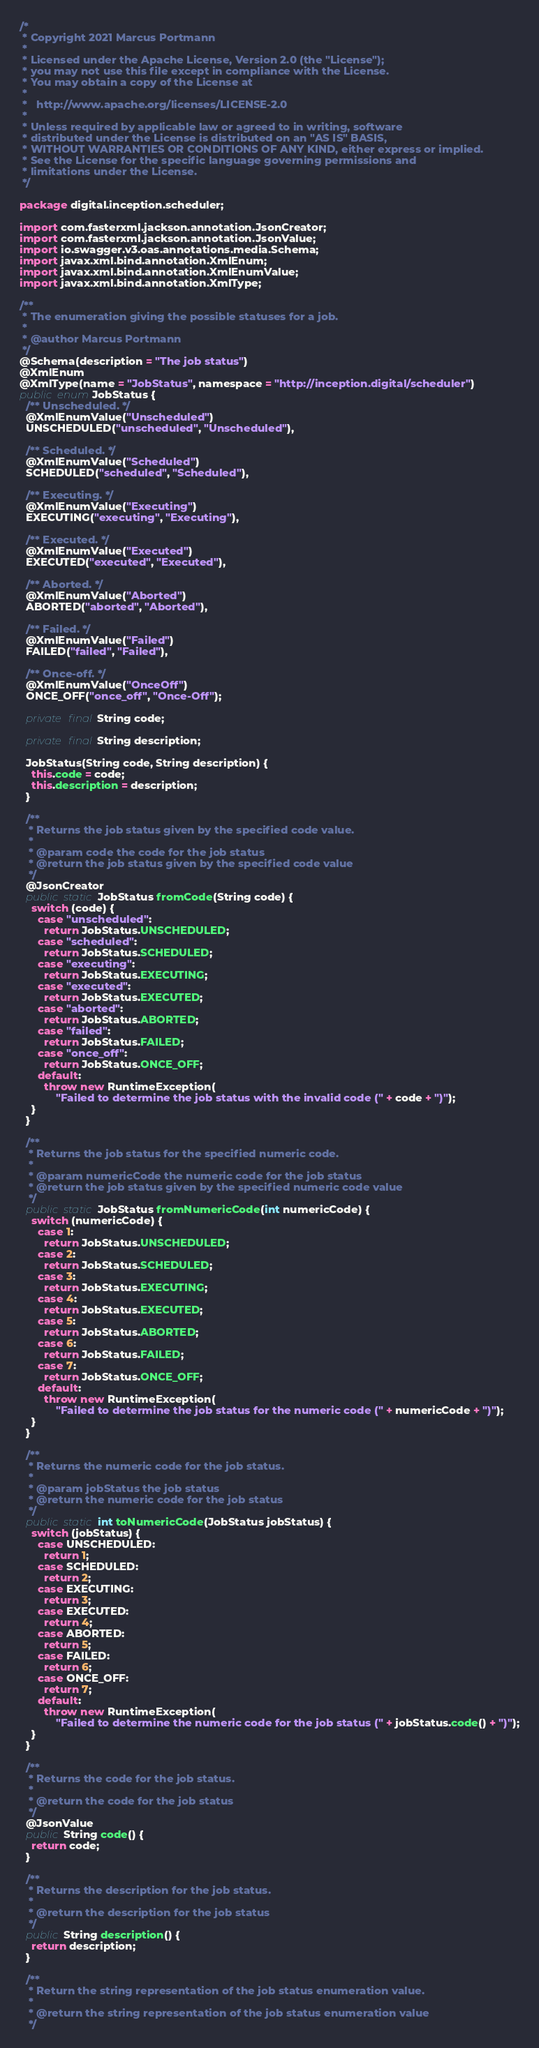Convert code to text. <code><loc_0><loc_0><loc_500><loc_500><_Java_>/*
 * Copyright 2021 Marcus Portmann
 *
 * Licensed under the Apache License, Version 2.0 (the "License");
 * you may not use this file except in compliance with the License.
 * You may obtain a copy of the License at
 *
 *   http://www.apache.org/licenses/LICENSE-2.0
 *
 * Unless required by applicable law or agreed to in writing, software
 * distributed under the License is distributed on an "AS IS" BASIS,
 * WITHOUT WARRANTIES OR CONDITIONS OF ANY KIND, either express or implied.
 * See the License for the specific language governing permissions and
 * limitations under the License.
 */

package digital.inception.scheduler;

import com.fasterxml.jackson.annotation.JsonCreator;
import com.fasterxml.jackson.annotation.JsonValue;
import io.swagger.v3.oas.annotations.media.Schema;
import javax.xml.bind.annotation.XmlEnum;
import javax.xml.bind.annotation.XmlEnumValue;
import javax.xml.bind.annotation.XmlType;

/**
 * The enumeration giving the possible statuses for a job.
 *
 * @author Marcus Portmann
 */
@Schema(description = "The job status")
@XmlEnum
@XmlType(name = "JobStatus", namespace = "http://inception.digital/scheduler")
public enum JobStatus {
  /** Unscheduled. */
  @XmlEnumValue("Unscheduled")
  UNSCHEDULED("unscheduled", "Unscheduled"),

  /** Scheduled. */
  @XmlEnumValue("Scheduled")
  SCHEDULED("scheduled", "Scheduled"),

  /** Executing. */
  @XmlEnumValue("Executing")
  EXECUTING("executing", "Executing"),

  /** Executed. */
  @XmlEnumValue("Executed")
  EXECUTED("executed", "Executed"),

  /** Aborted. */
  @XmlEnumValue("Aborted")
  ABORTED("aborted", "Aborted"),

  /** Failed. */
  @XmlEnumValue("Failed")
  FAILED("failed", "Failed"),

  /** Once-off. */
  @XmlEnumValue("OnceOff")
  ONCE_OFF("once_off", "Once-Off");

  private final String code;

  private final String description;

  JobStatus(String code, String description) {
    this.code = code;
    this.description = description;
  }

  /**
   * Returns the job status given by the specified code value.
   *
   * @param code the code for the job status
   * @return the job status given by the specified code value
   */
  @JsonCreator
  public static JobStatus fromCode(String code) {
    switch (code) {
      case "unscheduled":
        return JobStatus.UNSCHEDULED;
      case "scheduled":
        return JobStatus.SCHEDULED;
      case "executing":
        return JobStatus.EXECUTING;
      case "executed":
        return JobStatus.EXECUTED;
      case "aborted":
        return JobStatus.ABORTED;
      case "failed":
        return JobStatus.FAILED;
      case "once_off":
        return JobStatus.ONCE_OFF;
      default:
        throw new RuntimeException(
            "Failed to determine the job status with the invalid code (" + code + ")");
    }
  }

  /**
   * Returns the job status for the specified numeric code.
   *
   * @param numericCode the numeric code for the job status
   * @return the job status given by the specified numeric code value
   */
  public static JobStatus fromNumericCode(int numericCode) {
    switch (numericCode) {
      case 1:
        return JobStatus.UNSCHEDULED;
      case 2:
        return JobStatus.SCHEDULED;
      case 3:
        return JobStatus.EXECUTING;
      case 4:
        return JobStatus.EXECUTED;
      case 5:
        return JobStatus.ABORTED;
      case 6:
        return JobStatus.FAILED;
      case 7:
        return JobStatus.ONCE_OFF;
      default:
        throw new RuntimeException(
            "Failed to determine the job status for the numeric code (" + numericCode + ")");
    }
  }

  /**
   * Returns the numeric code for the job status.
   *
   * @param jobStatus the job status
   * @return the numeric code for the job status
   */
  public static int toNumericCode(JobStatus jobStatus) {
    switch (jobStatus) {
      case UNSCHEDULED:
        return 1;
      case SCHEDULED:
        return 2;
      case EXECUTING:
        return 3;
      case EXECUTED:
        return 4;
      case ABORTED:
        return 5;
      case FAILED:
        return 6;
      case ONCE_OFF:
        return 7;
      default:
        throw new RuntimeException(
            "Failed to determine the numeric code for the job status (" + jobStatus.code() + ")");
    }
  }

  /**
   * Returns the code for the job status.
   *
   * @return the code for the job status
   */
  @JsonValue
  public String code() {
    return code;
  }

  /**
   * Returns the description for the job status.
   *
   * @return the description for the job status
   */
  public String description() {
    return description;
  }

  /**
   * Return the string representation of the job status enumeration value.
   *
   * @return the string representation of the job status enumeration value
   */</code> 